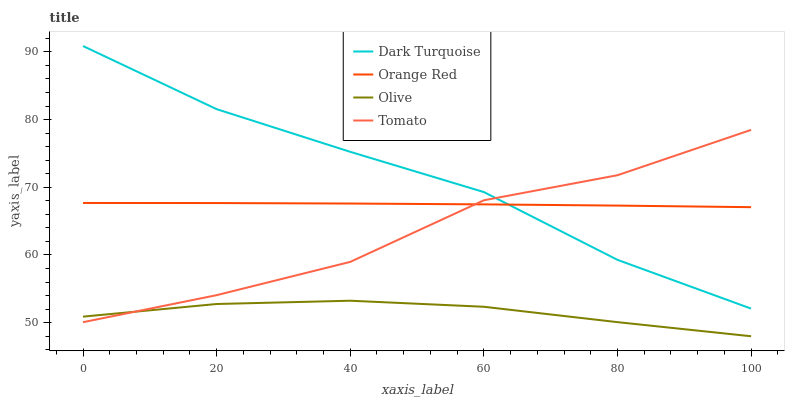Does Olive have the minimum area under the curve?
Answer yes or no. Yes. Does Dark Turquoise have the maximum area under the curve?
Answer yes or no. Yes. Does Tomato have the minimum area under the curve?
Answer yes or no. No. Does Tomato have the maximum area under the curve?
Answer yes or no. No. Is Orange Red the smoothest?
Answer yes or no. Yes. Is Tomato the roughest?
Answer yes or no. Yes. Is Dark Turquoise the smoothest?
Answer yes or no. No. Is Dark Turquoise the roughest?
Answer yes or no. No. Does Olive have the lowest value?
Answer yes or no. Yes. Does Dark Turquoise have the lowest value?
Answer yes or no. No. Does Dark Turquoise have the highest value?
Answer yes or no. Yes. Does Tomato have the highest value?
Answer yes or no. No. Is Olive less than Dark Turquoise?
Answer yes or no. Yes. Is Dark Turquoise greater than Olive?
Answer yes or no. Yes. Does Tomato intersect Dark Turquoise?
Answer yes or no. Yes. Is Tomato less than Dark Turquoise?
Answer yes or no. No. Is Tomato greater than Dark Turquoise?
Answer yes or no. No. Does Olive intersect Dark Turquoise?
Answer yes or no. No. 